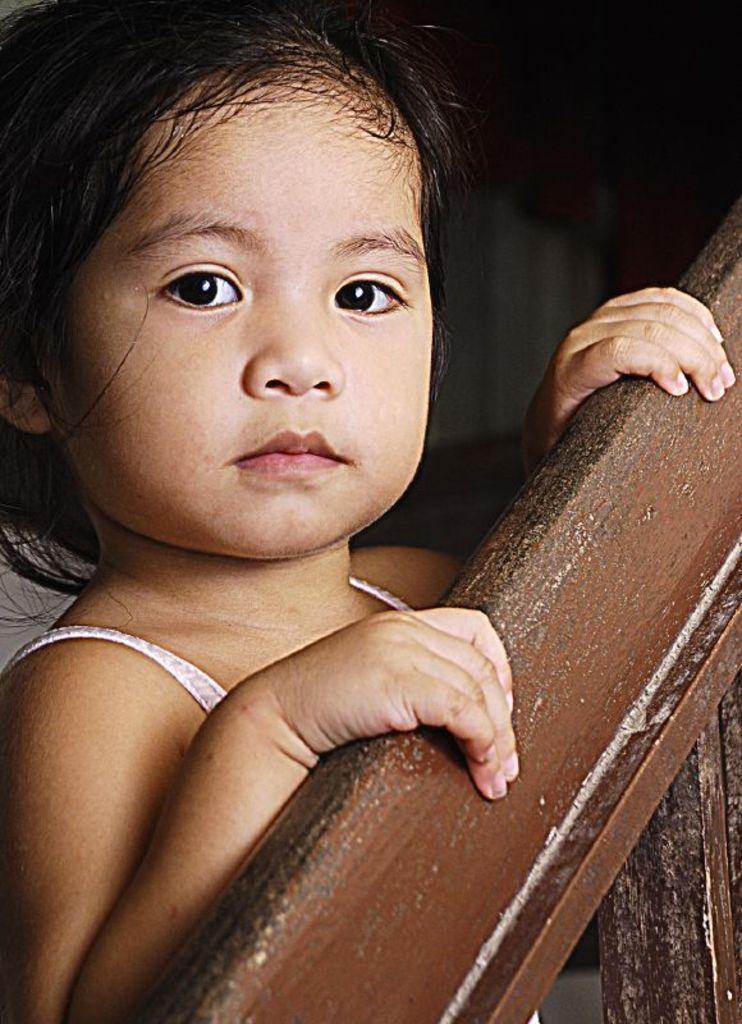Can you describe this image briefly? In this image I can see a girl standing. On the right side of the image there is a railing. 